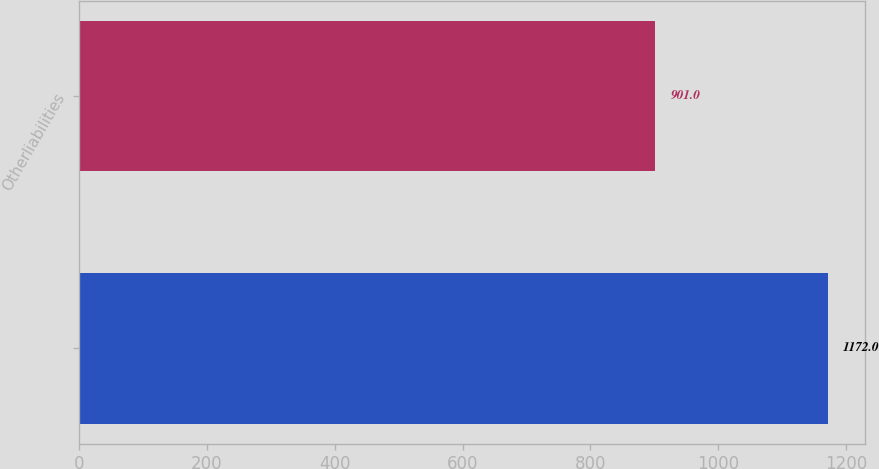Convert chart to OTSL. <chart><loc_0><loc_0><loc_500><loc_500><bar_chart><ecel><fcel>Otherliabilities<nl><fcel>1172<fcel>901<nl></chart> 